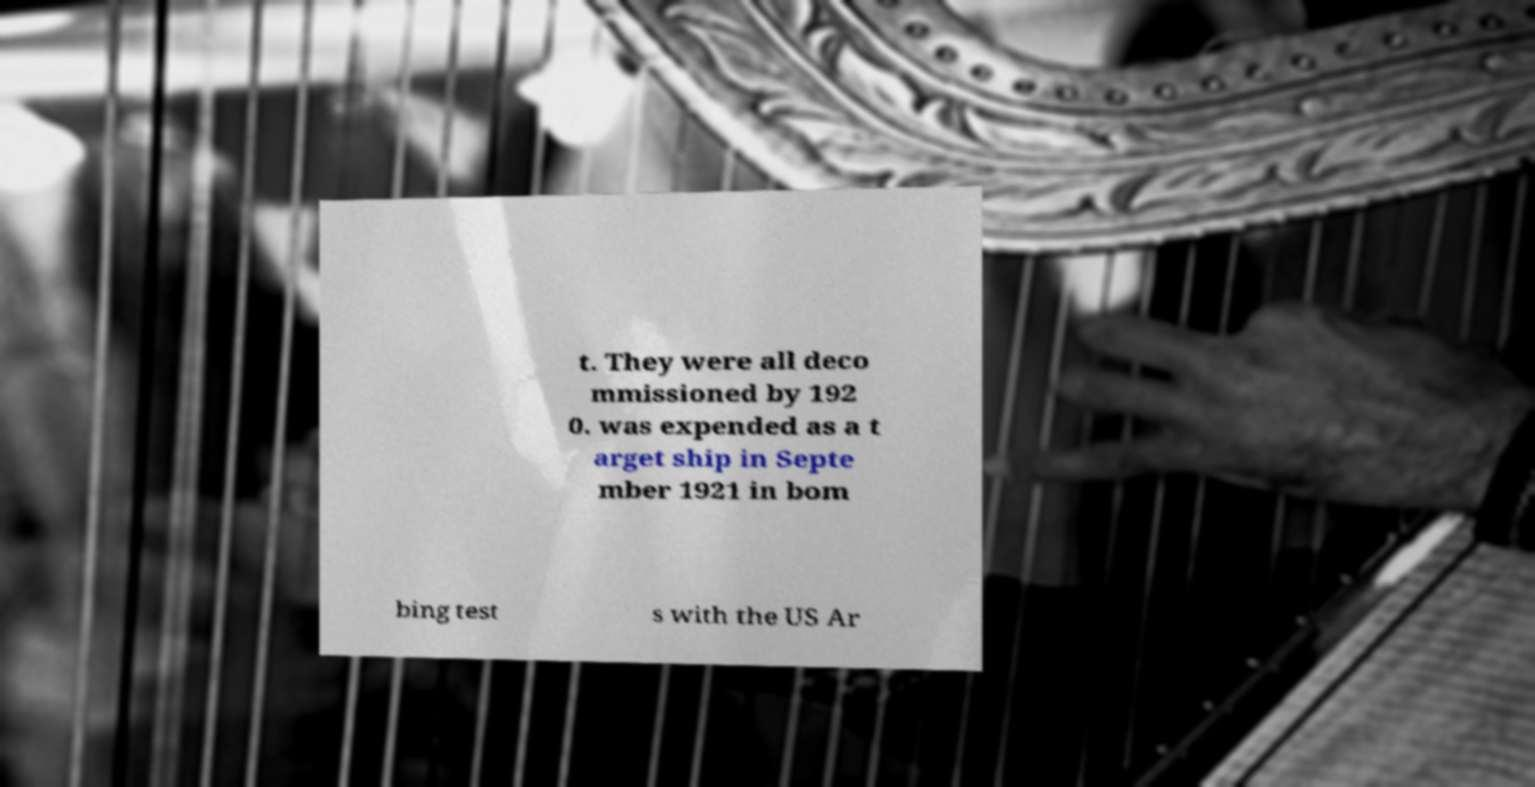Please read and relay the text visible in this image. What does it say? t. They were all deco mmissioned by 192 0. was expended as a t arget ship in Septe mber 1921 in bom bing test s with the US Ar 